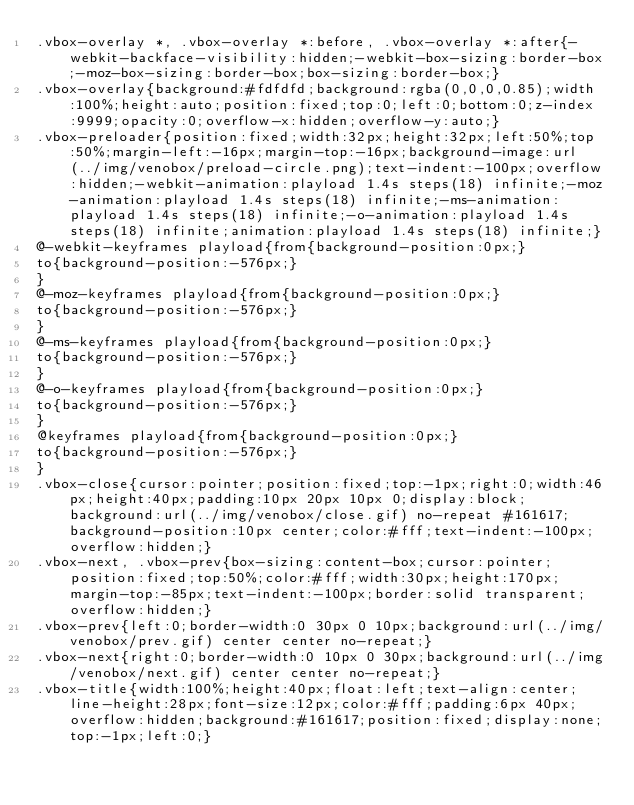<code> <loc_0><loc_0><loc_500><loc_500><_CSS_>.vbox-overlay *, .vbox-overlay *:before, .vbox-overlay *:after{-webkit-backface-visibility:hidden;-webkit-box-sizing:border-box;-moz-box-sizing:border-box;box-sizing:border-box;}
.vbox-overlay{background:#fdfdfd;background:rgba(0,0,0,0.85);width:100%;height:auto;position:fixed;top:0;left:0;bottom:0;z-index:9999;opacity:0;overflow-x:hidden;overflow-y:auto;}
.vbox-preloader{position:fixed;width:32px;height:32px;left:50%;top:50%;margin-left:-16px;margin-top:-16px;background-image:url(../img/venobox/preload-circle.png);text-indent:-100px;overflow:hidden;-webkit-animation:playload 1.4s steps(18) infinite;-moz-animation:playload 1.4s steps(18) infinite;-ms-animation:playload 1.4s steps(18) infinite;-o-animation:playload 1.4s steps(18) infinite;animation:playload 1.4s steps(18) infinite;}
@-webkit-keyframes playload{from{background-position:0px;}
to{background-position:-576px;}
}
@-moz-keyframes playload{from{background-position:0px;}
to{background-position:-576px;}
}
@-ms-keyframes playload{from{background-position:0px;}
to{background-position:-576px;}
}
@-o-keyframes playload{from{background-position:0px;}
to{background-position:-576px;}
}
@keyframes playload{from{background-position:0px;}
to{background-position:-576px;}
}
.vbox-close{cursor:pointer;position:fixed;top:-1px;right:0;width:46px;height:40px;padding:10px 20px 10px 0;display:block;background:url(../img/venobox/close.gif) no-repeat #161617;background-position:10px center;color:#fff;text-indent:-100px;overflow:hidden;}
.vbox-next, .vbox-prev{box-sizing:content-box;cursor:pointer;position:fixed;top:50%;color:#fff;width:30px;height:170px;margin-top:-85px;text-indent:-100px;border:solid transparent;overflow:hidden;}
.vbox-prev{left:0;border-width:0 30px 0 10px;background:url(../img/venobox/prev.gif) center center no-repeat;}
.vbox-next{right:0;border-width:0 10px 0 30px;background:url(../img/venobox/next.gif) center center no-repeat;}
.vbox-title{width:100%;height:40px;float:left;text-align:center;line-height:28px;font-size:12px;color:#fff;padding:6px 40px;overflow:hidden;background:#161617;position:fixed;display:none;top:-1px;left:0;}</code> 